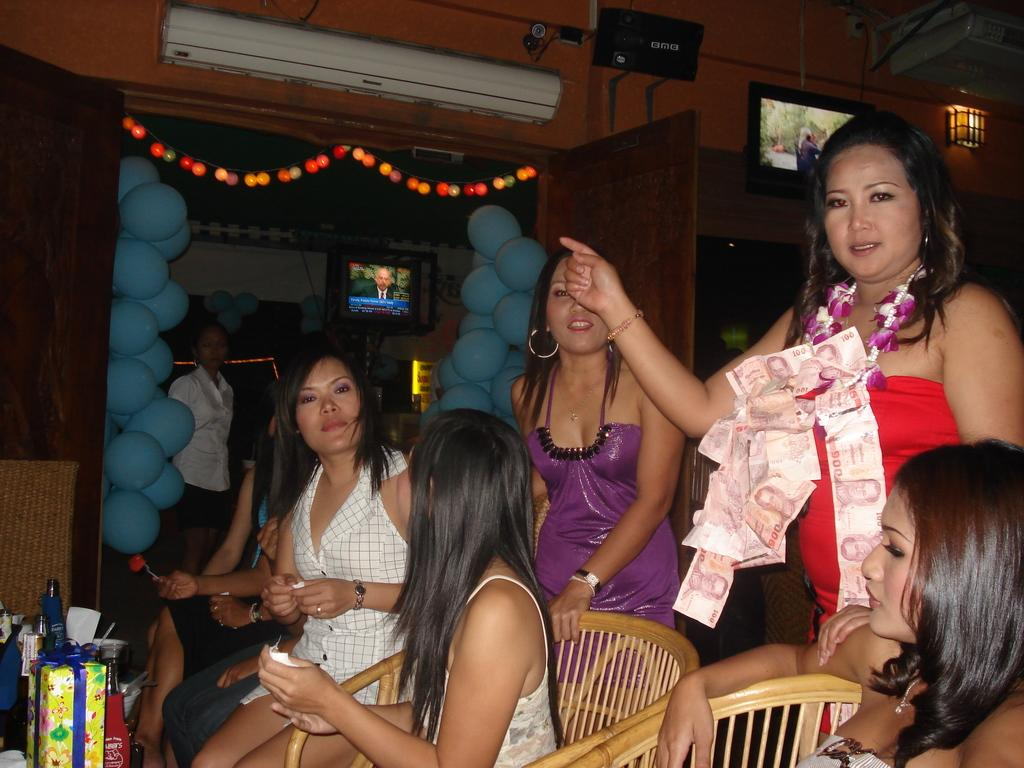Who or what is present in the image? There is a person in the image. What type of furniture can be seen in the image? There are chairs in the image. What electronic device is visible in the image? There is a television in the image. What decorative items are present in the image? There are balloons in the image. What appliance is used for cooling in the image? There is an AC in the image. What source of light is present in the image? There is a light in the image. What type of entryway is visible in the image? There is a door in the image. What item is used for hydration in the image? There is a water bottle in the image. What type of sidewalk can be seen in the image? There is no sidewalk present in the image. What boundary is visible in the image? There is no boundary present in the image. What type of hospital is depicted in the image? There is no hospital present in the image. 